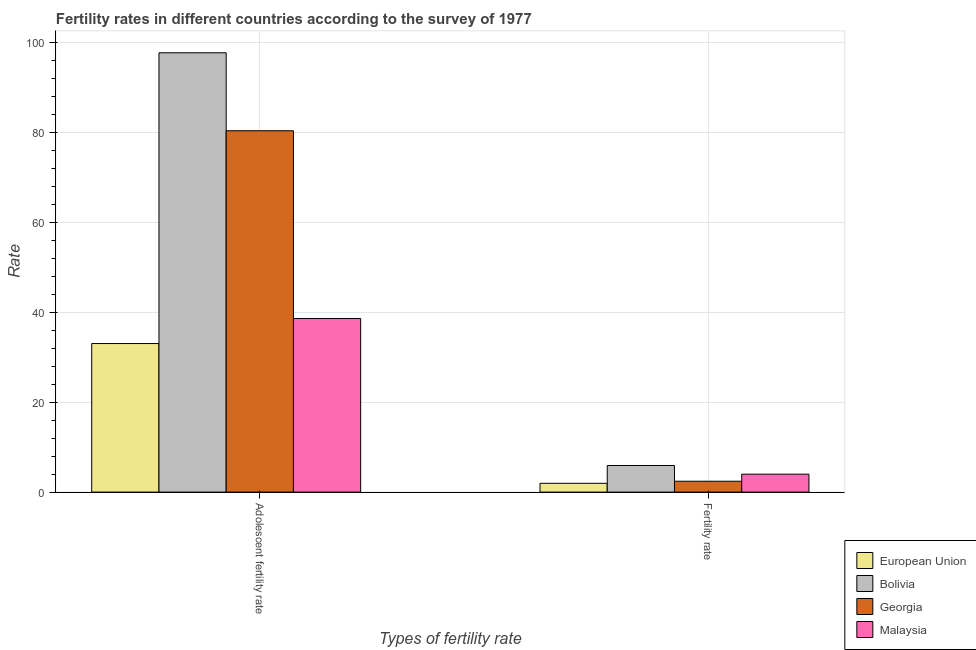How many groups of bars are there?
Provide a short and direct response. 2. How many bars are there on the 2nd tick from the right?
Offer a very short reply. 4. What is the label of the 1st group of bars from the left?
Keep it short and to the point. Adolescent fertility rate. What is the adolescent fertility rate in Malaysia?
Your answer should be very brief. 38.6. Across all countries, what is the maximum fertility rate?
Offer a very short reply. 5.92. Across all countries, what is the minimum fertility rate?
Your response must be concise. 1.96. In which country was the fertility rate minimum?
Your answer should be very brief. European Union. What is the total adolescent fertility rate in the graph?
Your answer should be compact. 249.68. What is the difference between the fertility rate in Bolivia and that in Malaysia?
Make the answer very short. 1.93. What is the difference between the adolescent fertility rate in Malaysia and the fertility rate in Bolivia?
Provide a succinct answer. 32.68. What is the average fertility rate per country?
Your answer should be very brief. 3.57. What is the difference between the fertility rate and adolescent fertility rate in Bolivia?
Provide a succinct answer. -91.77. In how many countries, is the adolescent fertility rate greater than 20 ?
Your response must be concise. 4. What is the ratio of the fertility rate in Malaysia to that in Georgia?
Your response must be concise. 1.65. What does the 2nd bar from the left in Fertility rate represents?
Provide a short and direct response. Bolivia. What does the 2nd bar from the right in Fertility rate represents?
Ensure brevity in your answer.  Georgia. Are all the bars in the graph horizontal?
Your answer should be very brief. No. Does the graph contain any zero values?
Ensure brevity in your answer.  No. How many legend labels are there?
Your answer should be very brief. 4. What is the title of the graph?
Your answer should be compact. Fertility rates in different countries according to the survey of 1977. Does "Nigeria" appear as one of the legend labels in the graph?
Your answer should be compact. No. What is the label or title of the X-axis?
Offer a very short reply. Types of fertility rate. What is the label or title of the Y-axis?
Make the answer very short. Rate. What is the Rate of European Union in Adolescent fertility rate?
Your answer should be compact. 33.04. What is the Rate of Bolivia in Adolescent fertility rate?
Your response must be concise. 97.69. What is the Rate of Georgia in Adolescent fertility rate?
Give a very brief answer. 80.35. What is the Rate of Malaysia in Adolescent fertility rate?
Give a very brief answer. 38.6. What is the Rate in European Union in Fertility rate?
Your response must be concise. 1.96. What is the Rate in Bolivia in Fertility rate?
Provide a succinct answer. 5.92. What is the Rate in Georgia in Fertility rate?
Keep it short and to the point. 2.42. What is the Rate of Malaysia in Fertility rate?
Provide a succinct answer. 3.99. Across all Types of fertility rate, what is the maximum Rate of European Union?
Offer a terse response. 33.04. Across all Types of fertility rate, what is the maximum Rate in Bolivia?
Offer a very short reply. 97.69. Across all Types of fertility rate, what is the maximum Rate in Georgia?
Your answer should be very brief. 80.35. Across all Types of fertility rate, what is the maximum Rate in Malaysia?
Provide a short and direct response. 38.6. Across all Types of fertility rate, what is the minimum Rate of European Union?
Offer a very short reply. 1.96. Across all Types of fertility rate, what is the minimum Rate in Bolivia?
Your response must be concise. 5.92. Across all Types of fertility rate, what is the minimum Rate in Georgia?
Provide a succinct answer. 2.42. Across all Types of fertility rate, what is the minimum Rate of Malaysia?
Your response must be concise. 3.99. What is the total Rate in European Union in the graph?
Provide a succinct answer. 35. What is the total Rate of Bolivia in the graph?
Give a very brief answer. 103.61. What is the total Rate in Georgia in the graph?
Provide a short and direct response. 82.77. What is the total Rate in Malaysia in the graph?
Give a very brief answer. 42.59. What is the difference between the Rate of European Union in Adolescent fertility rate and that in Fertility rate?
Offer a terse response. 31.08. What is the difference between the Rate in Bolivia in Adolescent fertility rate and that in Fertility rate?
Offer a terse response. 91.77. What is the difference between the Rate in Georgia in Adolescent fertility rate and that in Fertility rate?
Your answer should be very brief. 77.93. What is the difference between the Rate in Malaysia in Adolescent fertility rate and that in Fertility rate?
Keep it short and to the point. 34.61. What is the difference between the Rate of European Union in Adolescent fertility rate and the Rate of Bolivia in Fertility rate?
Give a very brief answer. 27.12. What is the difference between the Rate of European Union in Adolescent fertility rate and the Rate of Georgia in Fertility rate?
Offer a terse response. 30.62. What is the difference between the Rate of European Union in Adolescent fertility rate and the Rate of Malaysia in Fertility rate?
Offer a terse response. 29.05. What is the difference between the Rate of Bolivia in Adolescent fertility rate and the Rate of Georgia in Fertility rate?
Provide a short and direct response. 95.27. What is the difference between the Rate of Bolivia in Adolescent fertility rate and the Rate of Malaysia in Fertility rate?
Offer a terse response. 93.7. What is the difference between the Rate of Georgia in Adolescent fertility rate and the Rate of Malaysia in Fertility rate?
Your answer should be very brief. 76.36. What is the average Rate in European Union per Types of fertility rate?
Your answer should be compact. 17.5. What is the average Rate in Bolivia per Types of fertility rate?
Keep it short and to the point. 51.8. What is the average Rate in Georgia per Types of fertility rate?
Offer a very short reply. 41.39. What is the average Rate of Malaysia per Types of fertility rate?
Ensure brevity in your answer.  21.29. What is the difference between the Rate of European Union and Rate of Bolivia in Adolescent fertility rate?
Offer a terse response. -64.65. What is the difference between the Rate in European Union and Rate in Georgia in Adolescent fertility rate?
Provide a succinct answer. -47.32. What is the difference between the Rate in European Union and Rate in Malaysia in Adolescent fertility rate?
Offer a very short reply. -5.56. What is the difference between the Rate in Bolivia and Rate in Georgia in Adolescent fertility rate?
Keep it short and to the point. 17.34. What is the difference between the Rate in Bolivia and Rate in Malaysia in Adolescent fertility rate?
Your answer should be compact. 59.09. What is the difference between the Rate in Georgia and Rate in Malaysia in Adolescent fertility rate?
Provide a succinct answer. 41.75. What is the difference between the Rate of European Union and Rate of Bolivia in Fertility rate?
Your response must be concise. -3.96. What is the difference between the Rate of European Union and Rate of Georgia in Fertility rate?
Your response must be concise. -0.46. What is the difference between the Rate of European Union and Rate of Malaysia in Fertility rate?
Your response must be concise. -2.03. What is the difference between the Rate of Bolivia and Rate of Georgia in Fertility rate?
Keep it short and to the point. 3.5. What is the difference between the Rate in Bolivia and Rate in Malaysia in Fertility rate?
Your response must be concise. 1.93. What is the difference between the Rate of Georgia and Rate of Malaysia in Fertility rate?
Make the answer very short. -1.57. What is the ratio of the Rate in European Union in Adolescent fertility rate to that in Fertility rate?
Provide a short and direct response. 16.87. What is the ratio of the Rate in Bolivia in Adolescent fertility rate to that in Fertility rate?
Your response must be concise. 16.51. What is the ratio of the Rate of Georgia in Adolescent fertility rate to that in Fertility rate?
Ensure brevity in your answer.  33.22. What is the ratio of the Rate in Malaysia in Adolescent fertility rate to that in Fertility rate?
Ensure brevity in your answer.  9.67. What is the difference between the highest and the second highest Rate in European Union?
Offer a terse response. 31.08. What is the difference between the highest and the second highest Rate in Bolivia?
Your response must be concise. 91.77. What is the difference between the highest and the second highest Rate in Georgia?
Your response must be concise. 77.93. What is the difference between the highest and the second highest Rate of Malaysia?
Provide a succinct answer. 34.61. What is the difference between the highest and the lowest Rate of European Union?
Your response must be concise. 31.08. What is the difference between the highest and the lowest Rate of Bolivia?
Offer a terse response. 91.77. What is the difference between the highest and the lowest Rate of Georgia?
Offer a very short reply. 77.93. What is the difference between the highest and the lowest Rate of Malaysia?
Make the answer very short. 34.61. 